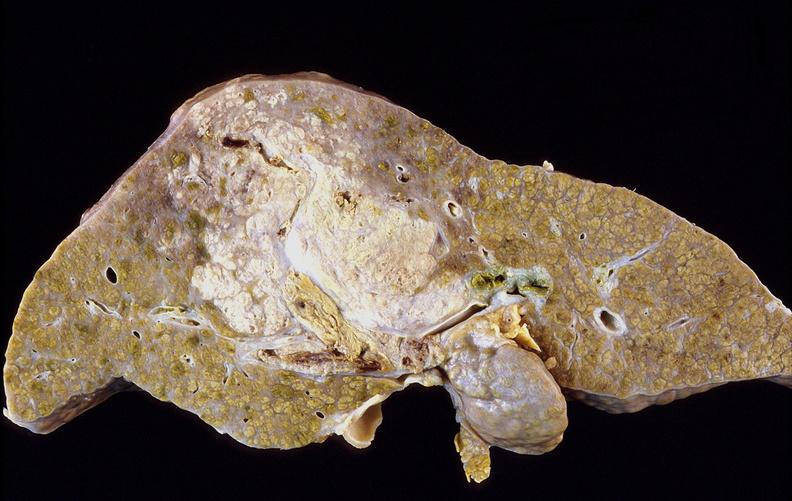s hepatobiliary present?
Answer the question using a single word or phrase. Yes 